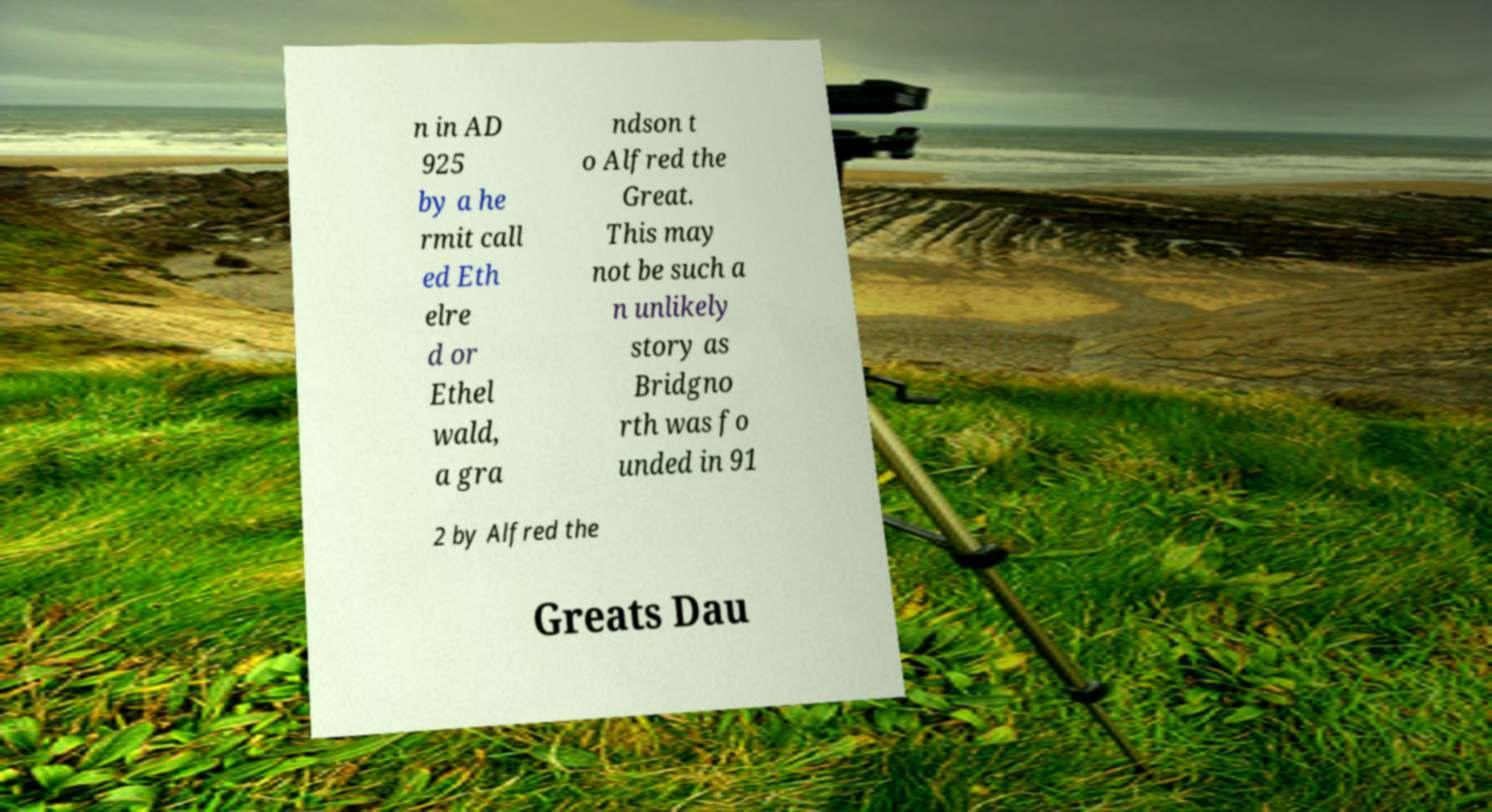Please identify and transcribe the text found in this image. n in AD 925 by a he rmit call ed Eth elre d or Ethel wald, a gra ndson t o Alfred the Great. This may not be such a n unlikely story as Bridgno rth was fo unded in 91 2 by Alfred the Greats Dau 